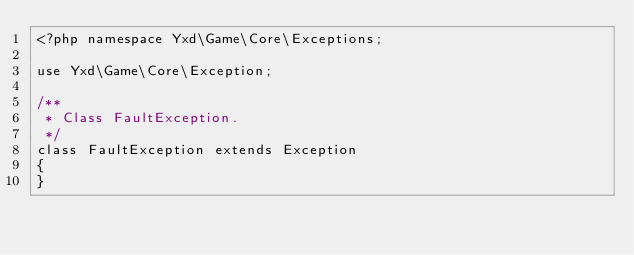<code> <loc_0><loc_0><loc_500><loc_500><_PHP_><?php namespace Yxd\Game\Core\Exceptions;

use Yxd\Game\Core\Exception;

/**
 * Class FaultException.
 */
class FaultException extends Exception
{
}
</code> 